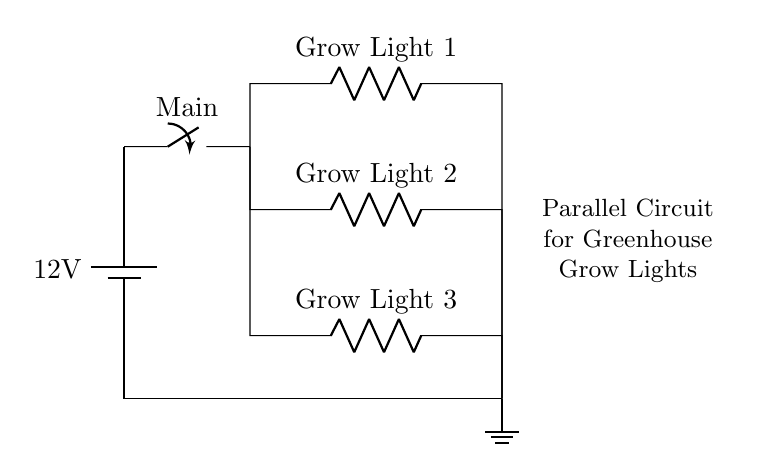What is the voltage of the power source? The voltage of the power source is labeled as 12 volts, indicated by the battery symbol.
Answer: 12 volts How many grow lights are there? There are three grow lights present in the circuit, as shown by the three resistor symbols labeled as Grow Light 1, Grow Light 2, and Grow Light 3.
Answer: Three What type of circuit is represented? The circuit diagram shows a parallel circuit, evident by the multiple branches connecting from the main power source to the grow lights independently.
Answer: Parallel What is the function of the main switch? The main switch is used to control the overall power supply to the circuit, allowing or interrupting the flow of electricity to all connected grow lights simultaneously.
Answer: Control If one grow light fails, what happens to the others? In a parallel circuit, if one grow light fails (i.e., if one branch is broken), the other grow lights continue to operate as their connections remain intact to the power source.
Answer: Others continue to operate What is the role of the ground in this circuit? The ground provides a return path for current and ensures safety by preventing unintended voltage build-up. It is essential for the stability of the circuit.
Answer: Safety and stability What is the current flow behavior in this circuit? In a parallel circuit, the total current from the power source is divided among the branches (grow lights), meaning each light can draw a different amount of current based on its resistance.
Answer: Divided among branches 